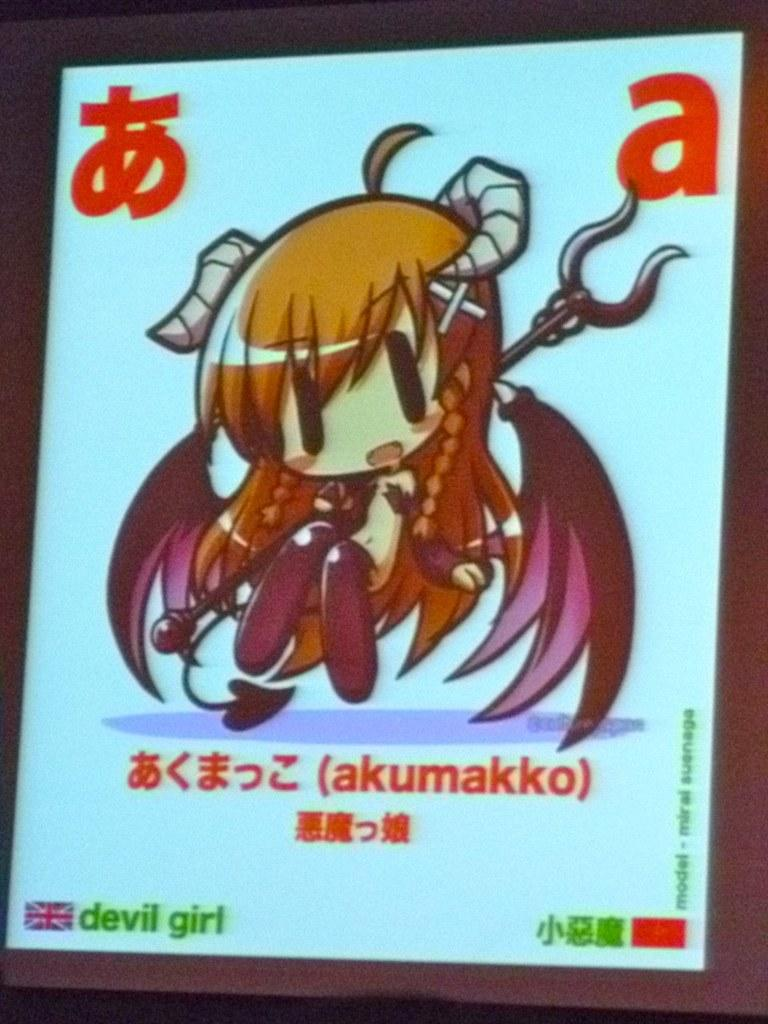<image>
Render a clear and concise summary of the photo. Tablet screen for Japanese animie for akumakko showing a horned girl with purple wings and a pitch fork. 